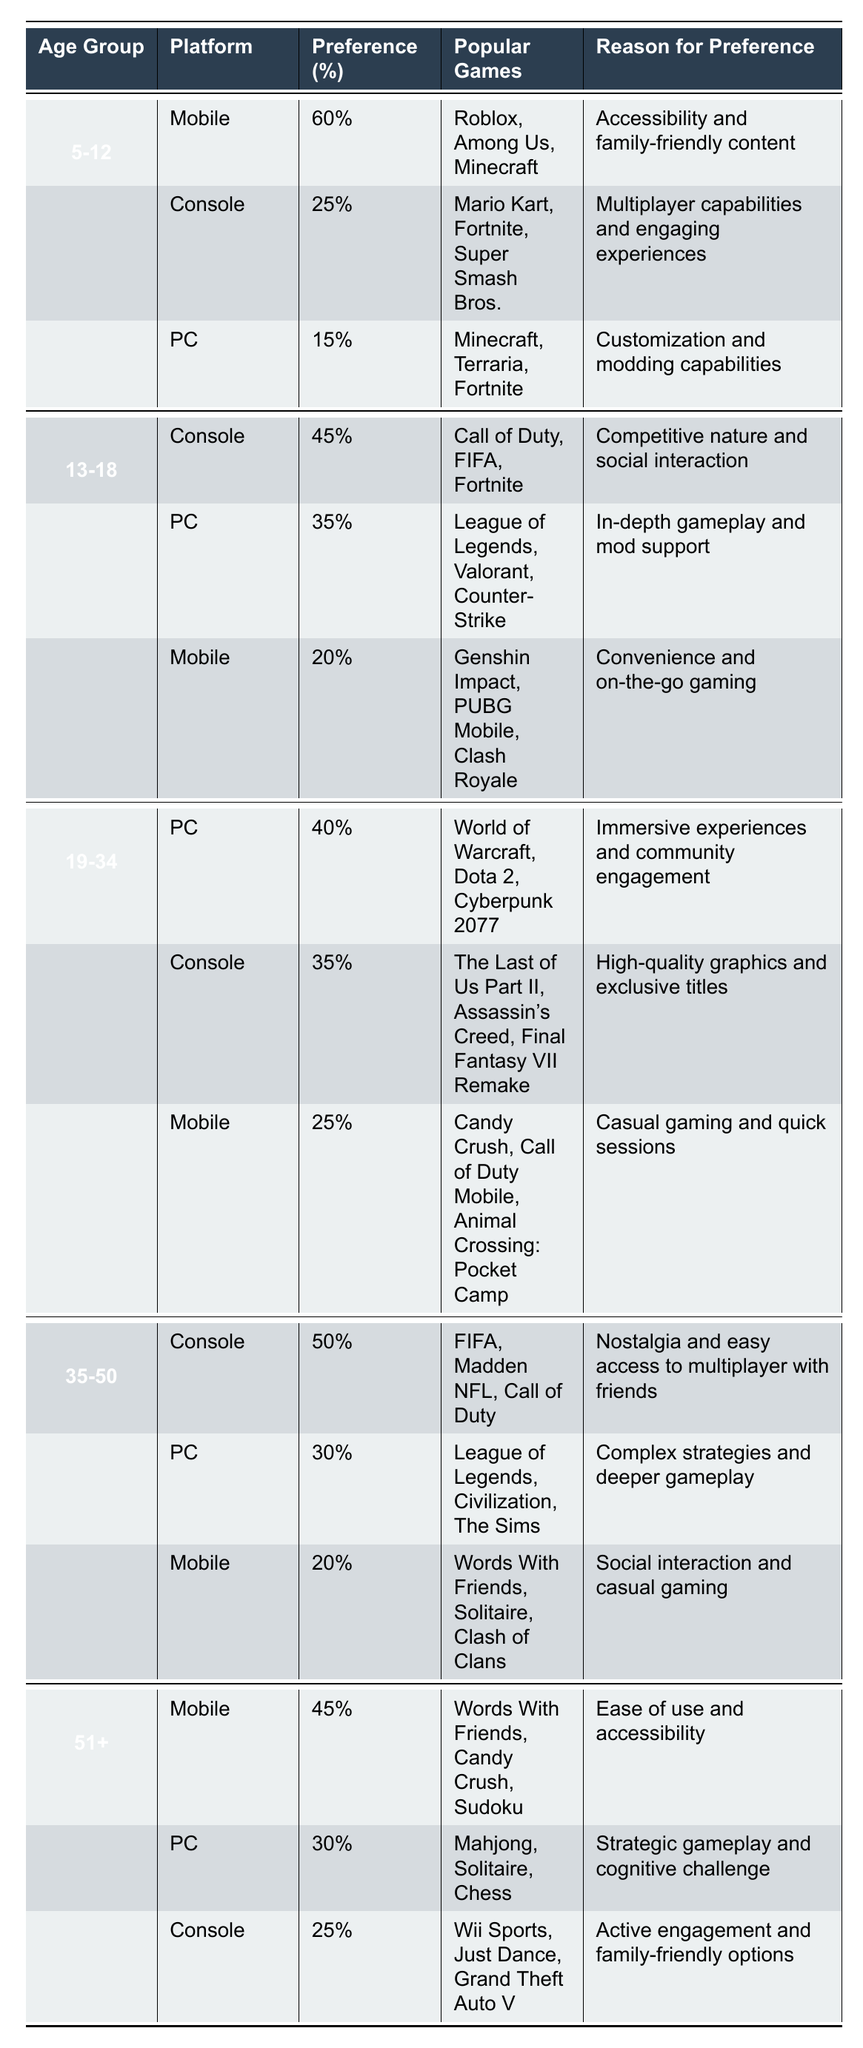What is the most preferred video game platform for the 5-12 age group? The most preferred platform for the 5-12 age group is Mobile, with a preference percentage of 60%. This is clearly indicated in the table under the "5-12" age group section.
Answer: Mobile Which platform has the highest preference percentage among the 35-50 age group? In the 35-50 age group, the platform with the highest preference percentage is Console, preferred by 50% of respondents. This information is directly available in the corresponding row of the table.
Answer: Console What percentage of the 13-18 age group prefers PC over Mobile? The preference for PC is 35%, while Mobile is 20% for the 13-18 age group. To find how much more they prefer PC over Mobile, we subtract: 35% - 20% = 15%. Therefore, the 13-18 age group prefers PC by 15%.
Answer: 15% Is it true that the majority of the 51+ age group prefers Console over Mobile? The preference percentage for Mobile is 45%, while for Console, it is 25%. Since 45% is greater than 25%, the statement is false.
Answer: No What is the total preference percentage for the Console among all age groups combined? We sum the Console preferences from each age group: 25% (5-12) + 45% (13-18) + 35% (19-34) + 50% (35-50) + 25% (51+) = 180%. Thus, the total preference percentage for the Console is 180%.
Answer: 180% Which popular game is equally favored by the 5-12 and 19-34 age groups based on the provided data? The game Minecraft is favored in both the 5-12 age group (under PC) and the 19-34 age group (also under PC). This is evident from the rows that list popular games for each age group.
Answer: Minecraft What reasons do the 19-34 age group have for preferring PC? The 19-34 age group prefers PC for two reasons: immersive experiences and community engagement. This information can be found in the corresponding row that describes the preference for PC within that age group.
Answer: Immersive experiences and community engagement How does the preference for Mobile compare between the 35-50 and 51+ age groups? For the 35-50 age group, the preference for Mobile is 20%, while for the 51+ age group, it is 45%. Comparing these values reveals that the 51+ age group prefers Mobile more than the 35-50 age group.
Answer: 21% more for 51+ 